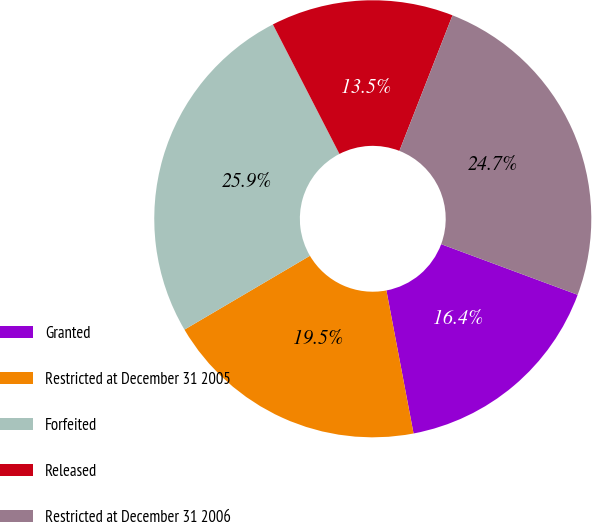Convert chart to OTSL. <chart><loc_0><loc_0><loc_500><loc_500><pie_chart><fcel>Granted<fcel>Restricted at December 31 2005<fcel>Forfeited<fcel>Released<fcel>Restricted at December 31 2006<nl><fcel>16.36%<fcel>19.52%<fcel>25.91%<fcel>13.5%<fcel>24.71%<nl></chart> 